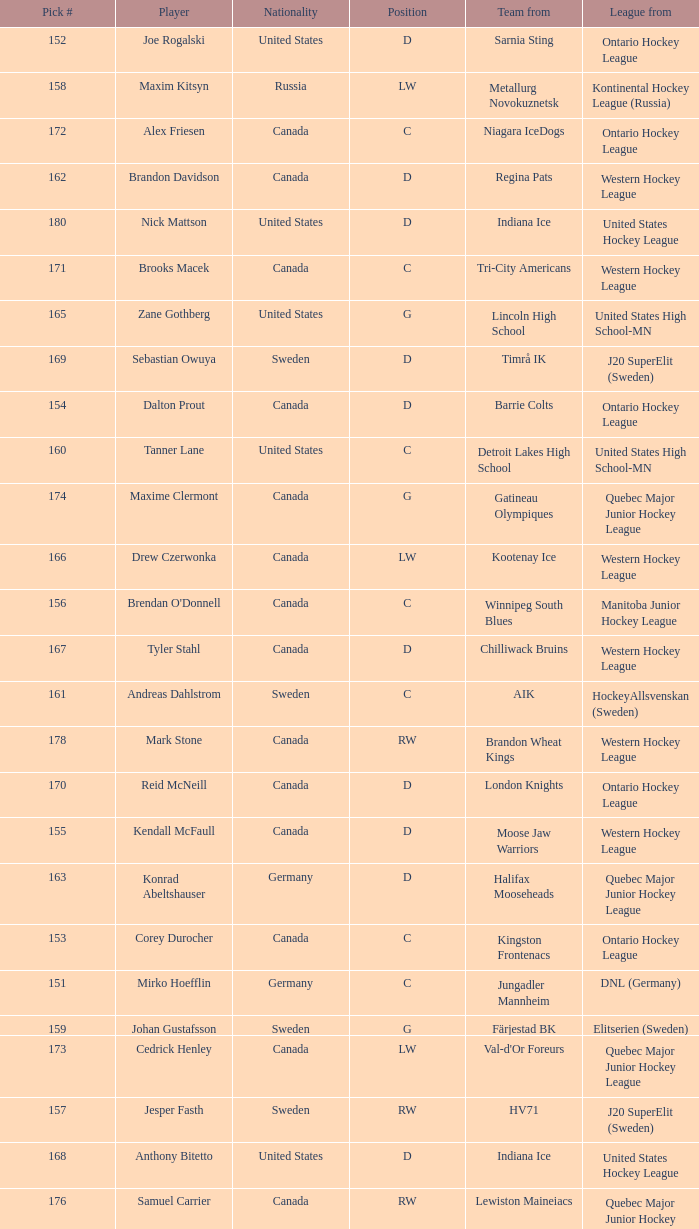What is the position of the team player from Aik? C. 